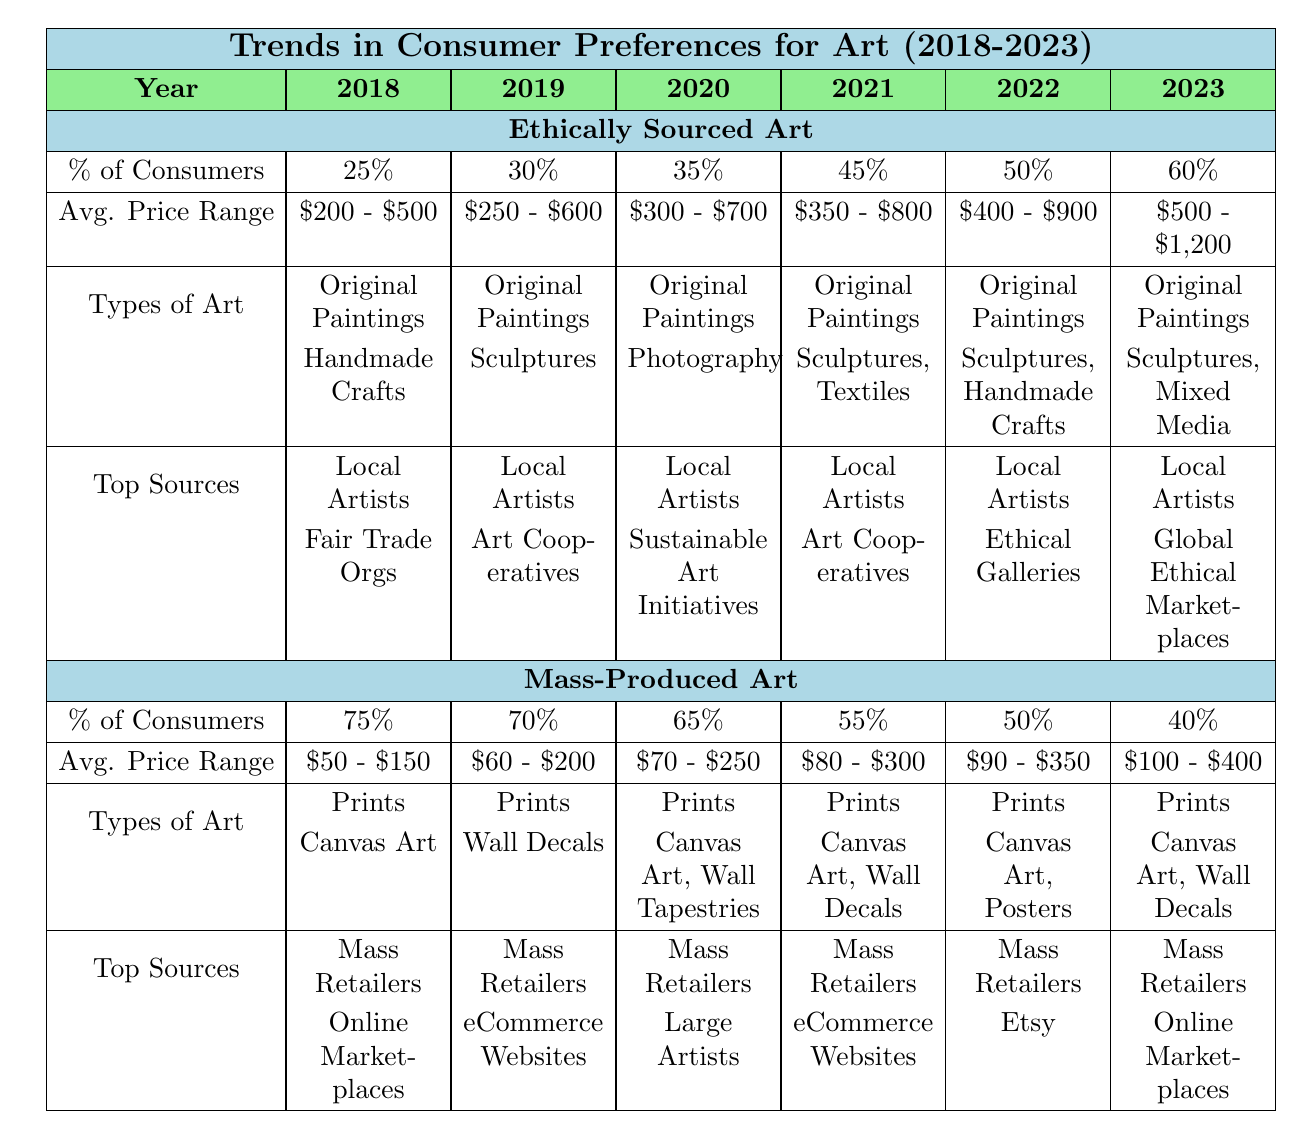What percentage of consumers preferred ethically sourced art in 2021? In 2021, the table shows the percentage of consumers preferring ethically sourced art was listed as 45%.
Answer: 45% What was the average price range for mass-produced art in 2023? In 2023, the average price range for mass-produced art is indicated as $100 - $400.
Answer: $100 - $400 How many types of art were listed for ethically sourced art in 2020? In 2020, the types of art listed under ethically sourced art were Original Paintings and Photography, which makes a total of 2 types.
Answer: 2 Is the percentage of consumers preferring mass-produced art decreasing over the years shown? Yes, the percentage of consumers preferring mass-produced art decreased from 75% in 2018 to 40% in 2023, indicating a consistent decline.
Answer: Yes What is the difference in the percentage of consumers preferring ethically sourced art between 2018 and 2023? The percentage of consumers preferring ethically sourced art in 2018 was 25%, and in 2023 it was 60%. The difference is 60% - 25% = 35%.
Answer: 35% What types of art became more diverse for ethically sourced art from 2018 to 2023? Over the years, types of art expanded from only Original Paintings in 2018 to include Sculptures, Mixed Media, and others by 2023, indicating a growth in diversity.
Answer: Sculptures, Mixed Media, and others Which source for ethically sourced art was consistently present throughout the years? The source "Local Artists" for ethically sourced art appeared consistently in every year from 2018 to 2023, while other sources varied.
Answer: Local Artists By what percentage did the average price range for ethically sourced art increase from 2018 to 2022? The average price range for ethically sourced art in 2018 was $200 - $500 and in 2022 it was $400 - $900. The price range indicates a $200 increase on the lower end and $400 increase on the upper end.
Answer: $200 increase How did the average price range of mass-produced art compare to ethically sourced art in 2023? In 2023, the average price range for mass-produced art was $100 - $400, while for ethically sourced art it was $500 - $1,200, showing that ethically sourced art was more expensive.
Answer: Ethically sourced art was more expensive What is the trend observed for the types of art preferred in mass-produced art from 2018 to 2023? The preferred types of art for mass-produced art remained predominantly Prints and Canvas Art throughout the years, with slight additions like Wall Decals and Posters in subsequent years.
Answer: Predominantly Prints and Canvas Art 